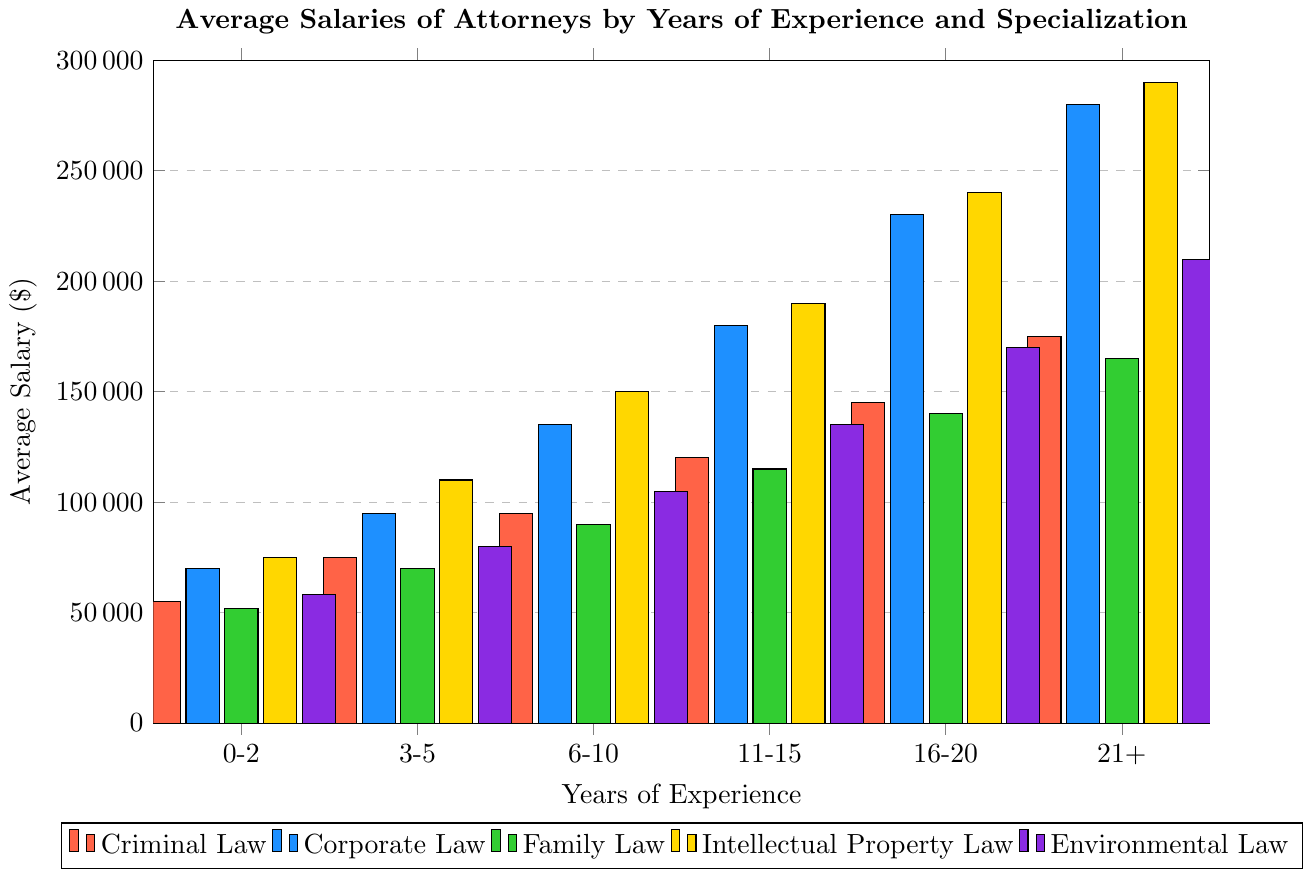What is the average salary of attorneys specializing in Criminal Law with 11-15 years of experience? The bar representing Criminal Law for 11-15 years of experience is at $120,000.
Answer: $120,000 Which specialization has the highest average salary for attorneys with 6-10 years of experience? For the 6-10 years of experience, the bars have the following values: Criminal Law ($95,000), Corporate Law ($135,000), Family Law ($90,000), Intellectual Property Law ($150,000), and Environmental Law ($105,000). The highest is Intellectual Property Law at $150,000.
Answer: Intellectual Property Law How much more do attorneys specializing in Corporate Law earn on average compared to Family Law attorneys for the 3-5 years of experience group? The average salary for Corporate Law is $95,000 and for Family Law is $70,000 in the 3-5 years experience group. The difference is $95,000 - $70,000 = $25,000.
Answer: $25,000 Which specialization sees the largest increase in average salary from the 0-2 years to the 21+ years experience group? The increases for each specialization are calculated as: 
- Criminal Law: $175,000 - $55,000 = $120,000
- Corporate Law: $280,000 - $70,000 = $210,000
- Family Law: $165,000 - $52,000 = $113,000
- Intellectual Property Law: $290,000 - $75,000 = $215,000
- Environmental Law: $210,000 - $58,000 = $152,000.
The largest increase is for Intellectual Property Law at $215,000.
Answer: Intellectual Property Law What is the color of the bar representing the average salary of attorneys in Environmental Law with 3-5 years of experience? The bar color for Environmental Law is purple, as defined in the plot.
Answer: Purple What's the average salary for a Family Law attorney with 16-20 years of experience compared to an Environmental Law attorney with 11-15 years of experience? The average salaries are Family Law ($140,000) and Environmental Law ($135,000) respectively. Since $140,000 is greater than $135,000, Family Law attorneys earn more.
Answer: Family Law attorneys earn more Which specialization has the highest slope in terms of salary increase from 3-5 years to 6-10 years of experience? The salary increases between these two years of experience are:
- Criminal Law: $95,000 - $75,000 = $20,000
- Corporate Law: $135,000 - $95,000 = $40,000
- Family Law: $90,000 - $70,000 = $20,000
- Intellectual Property Law: $150,000 - $110,000 = $40,000
- Environmental Law: $105,000 - $80,000 = $25,000.
Corporate Law and Intellectual Property Law both have the same maximum increase of $40,000.
Answer: Corporate Law and Intellectual Property Law How many years of experience are needed for Criminal Law attorneys to earn over $100,000 on average? Criminal Law attorneys earn over $100,000 starting in the 6-10 years experience group ($95,000), at the 11-15 years experience group ($120,000).
Answer: 11-15 years 